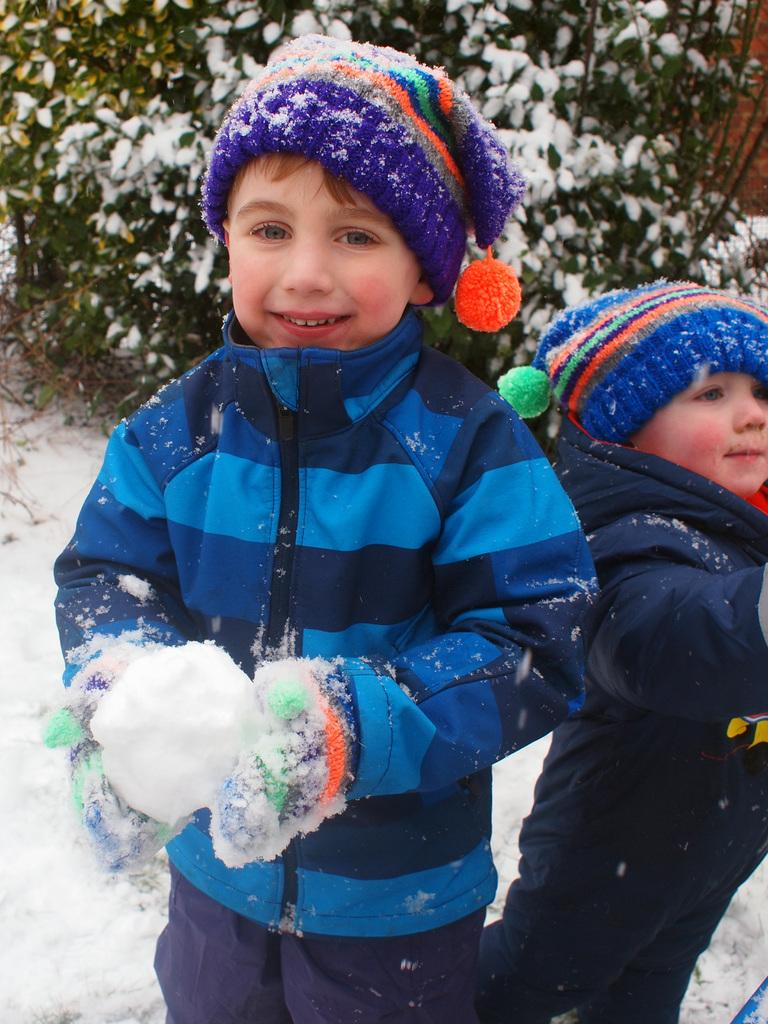How many children are present in the image? There are two children in the image. What are the children wearing on their heads? The children are wearing caps. What is the weather like in the image? There is snow in the image, indicating a cold and wintry setting. What can be seen in the background of the image? There are plants with snow in the background of the image. What type of car engine can be seen in the image? There is no car or engine present in the image; it features two children wearing caps in a snowy environment. 